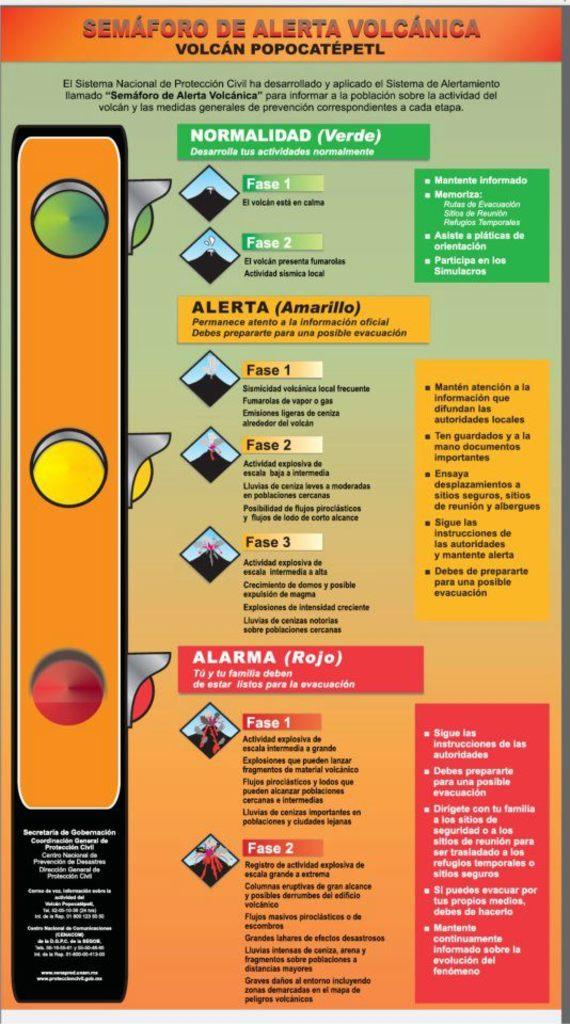<image>
Relay a brief, clear account of the picture shown. A chart showing different alert levels titled Semaforo De Alerta Volcanica. 